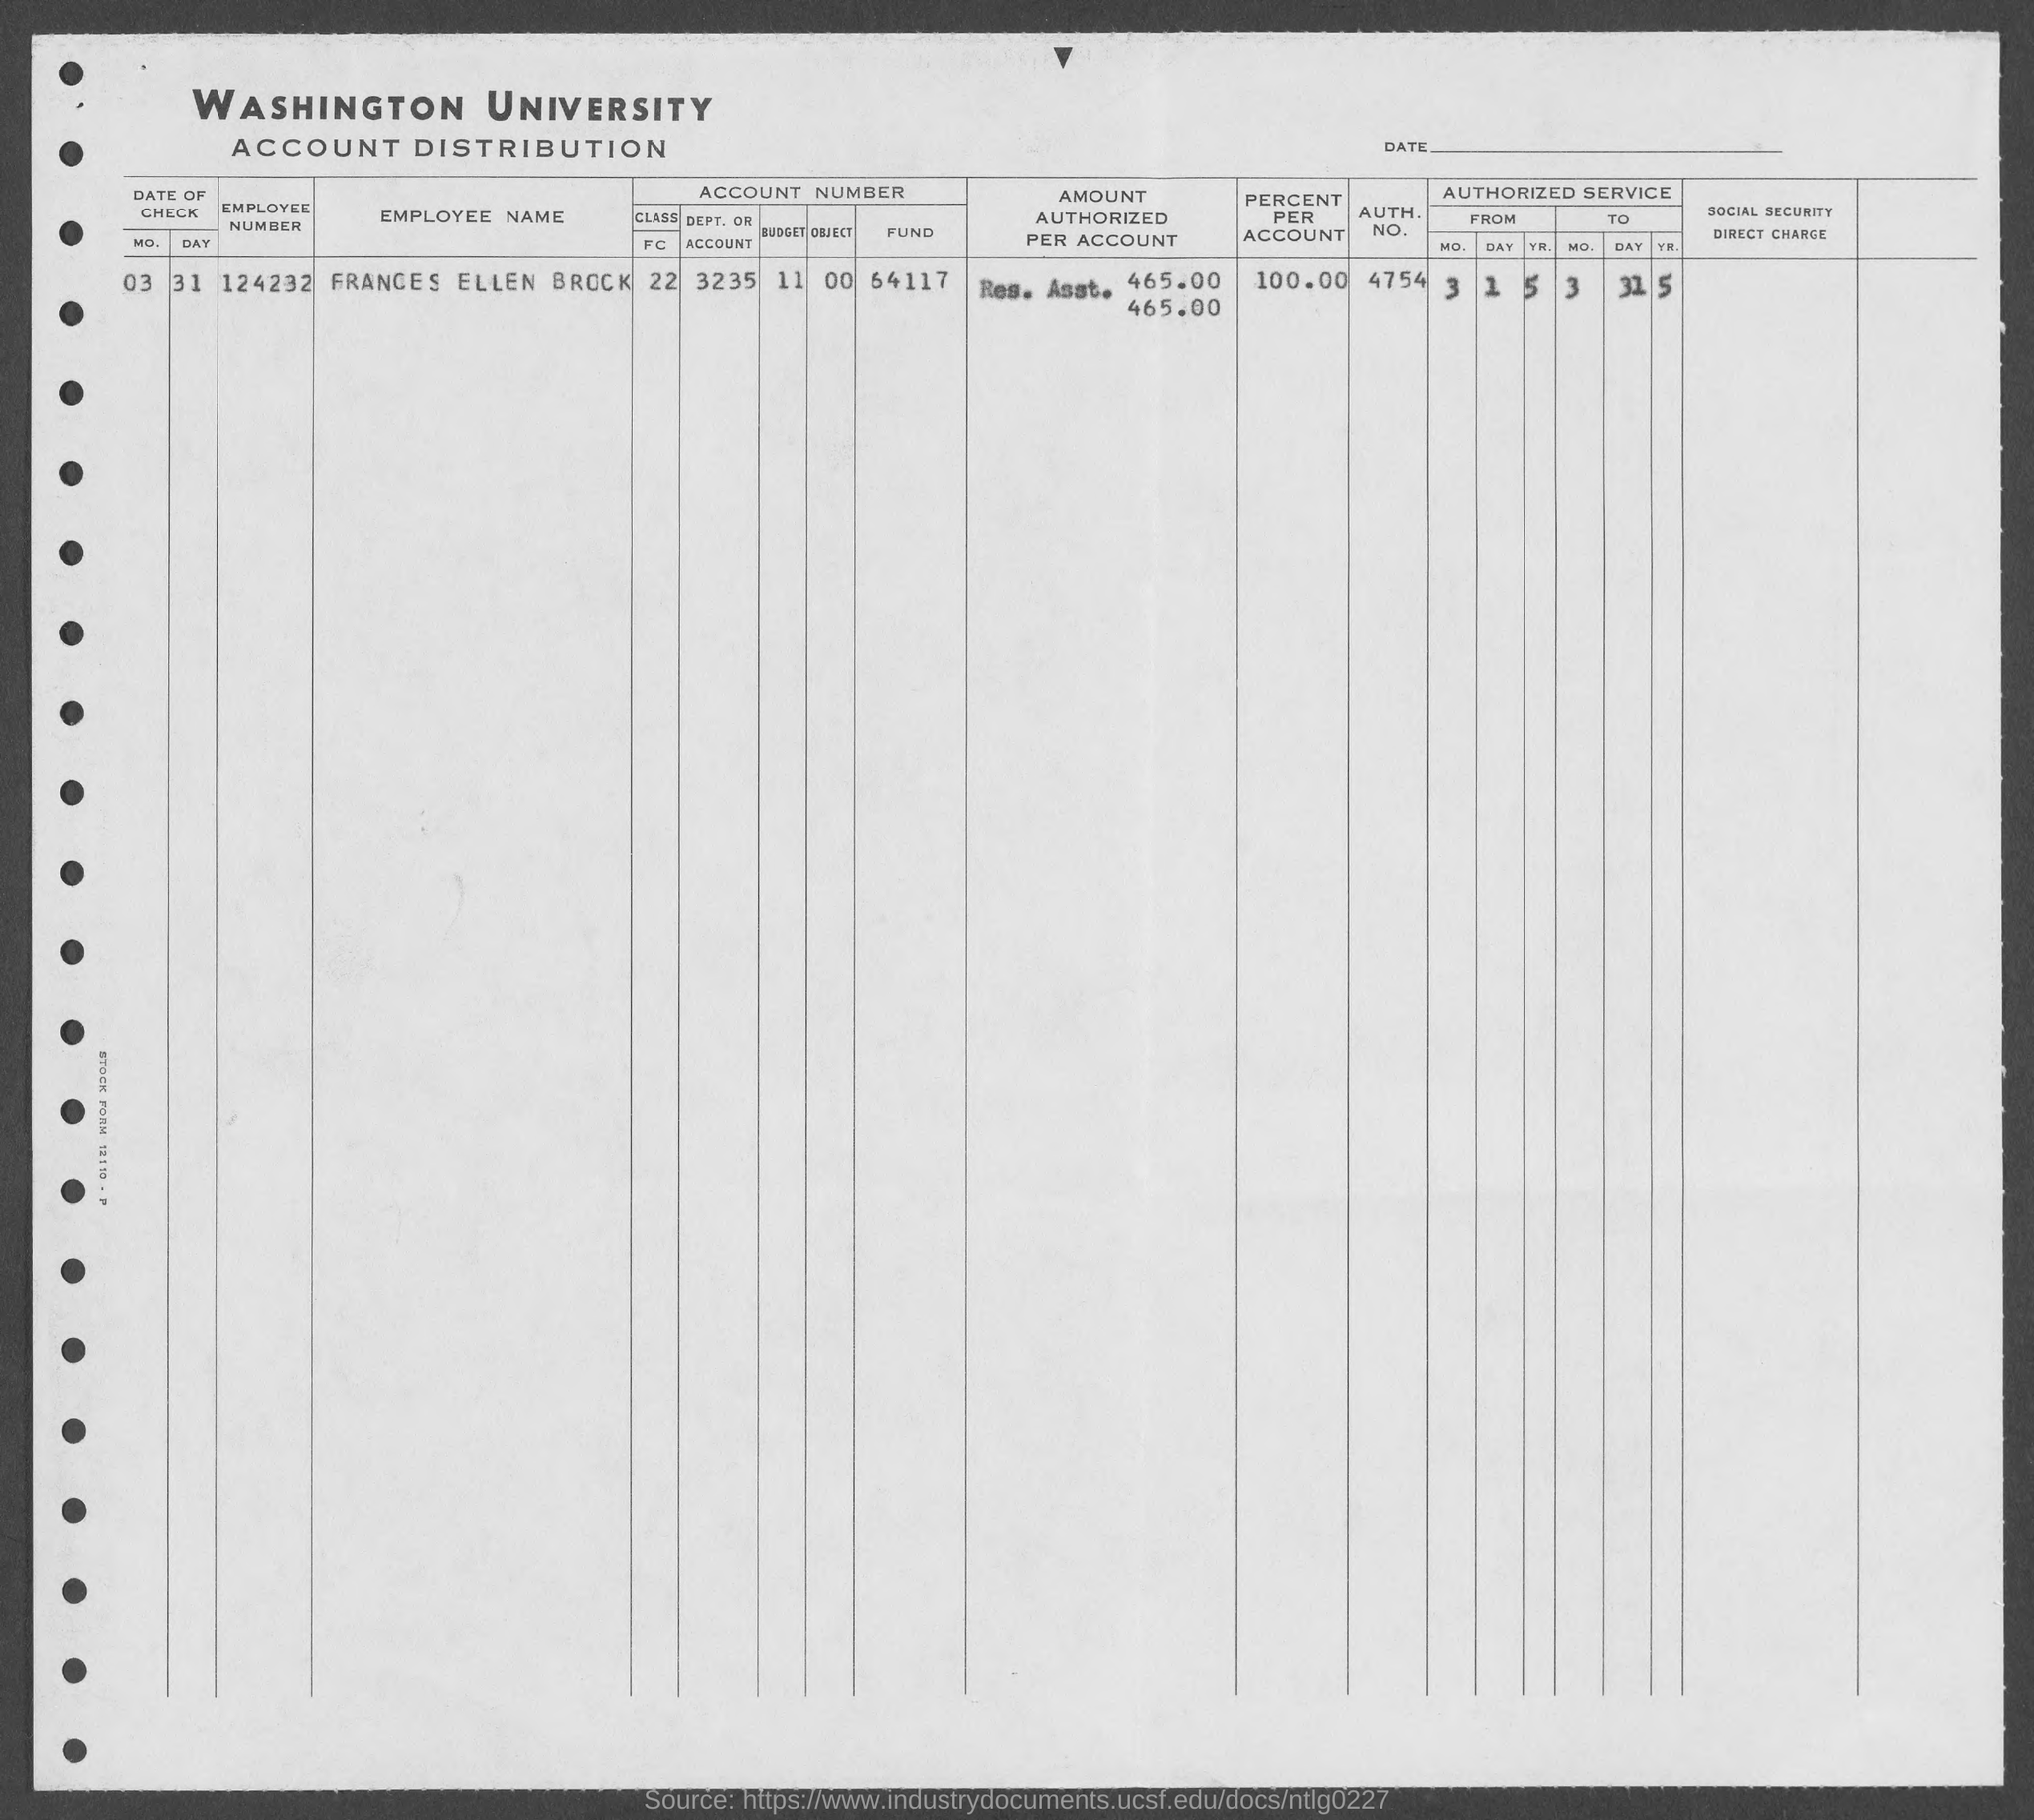What is the employee number of frances ellen brock?
Your answer should be compact. 124232. What is the auth. no. of frances ellen brock?
Offer a terse response. 4754. 